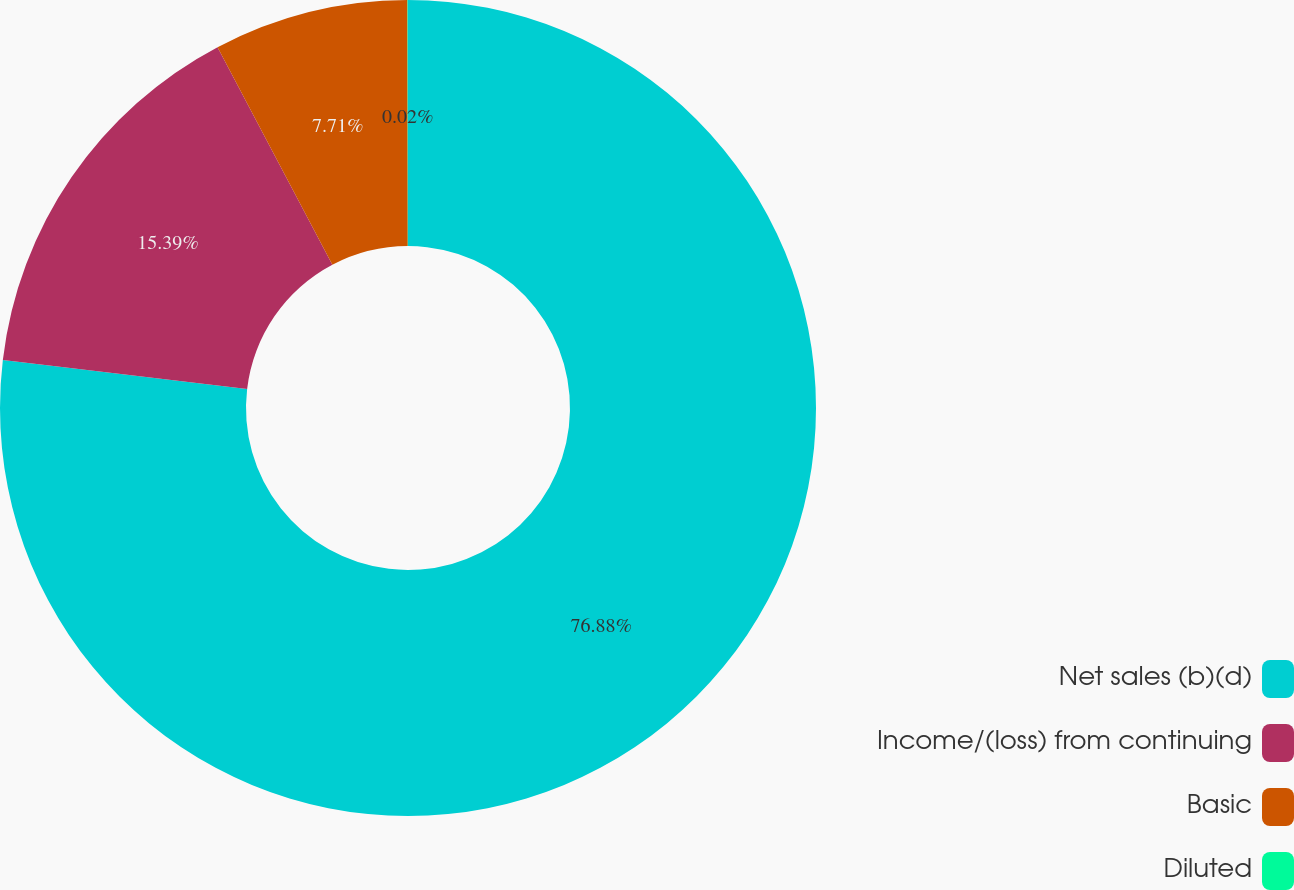Convert chart to OTSL. <chart><loc_0><loc_0><loc_500><loc_500><pie_chart><fcel>Net sales (b)(d)<fcel>Income/(loss) from continuing<fcel>Basic<fcel>Diluted<nl><fcel>76.88%<fcel>15.39%<fcel>7.71%<fcel>0.02%<nl></chart> 